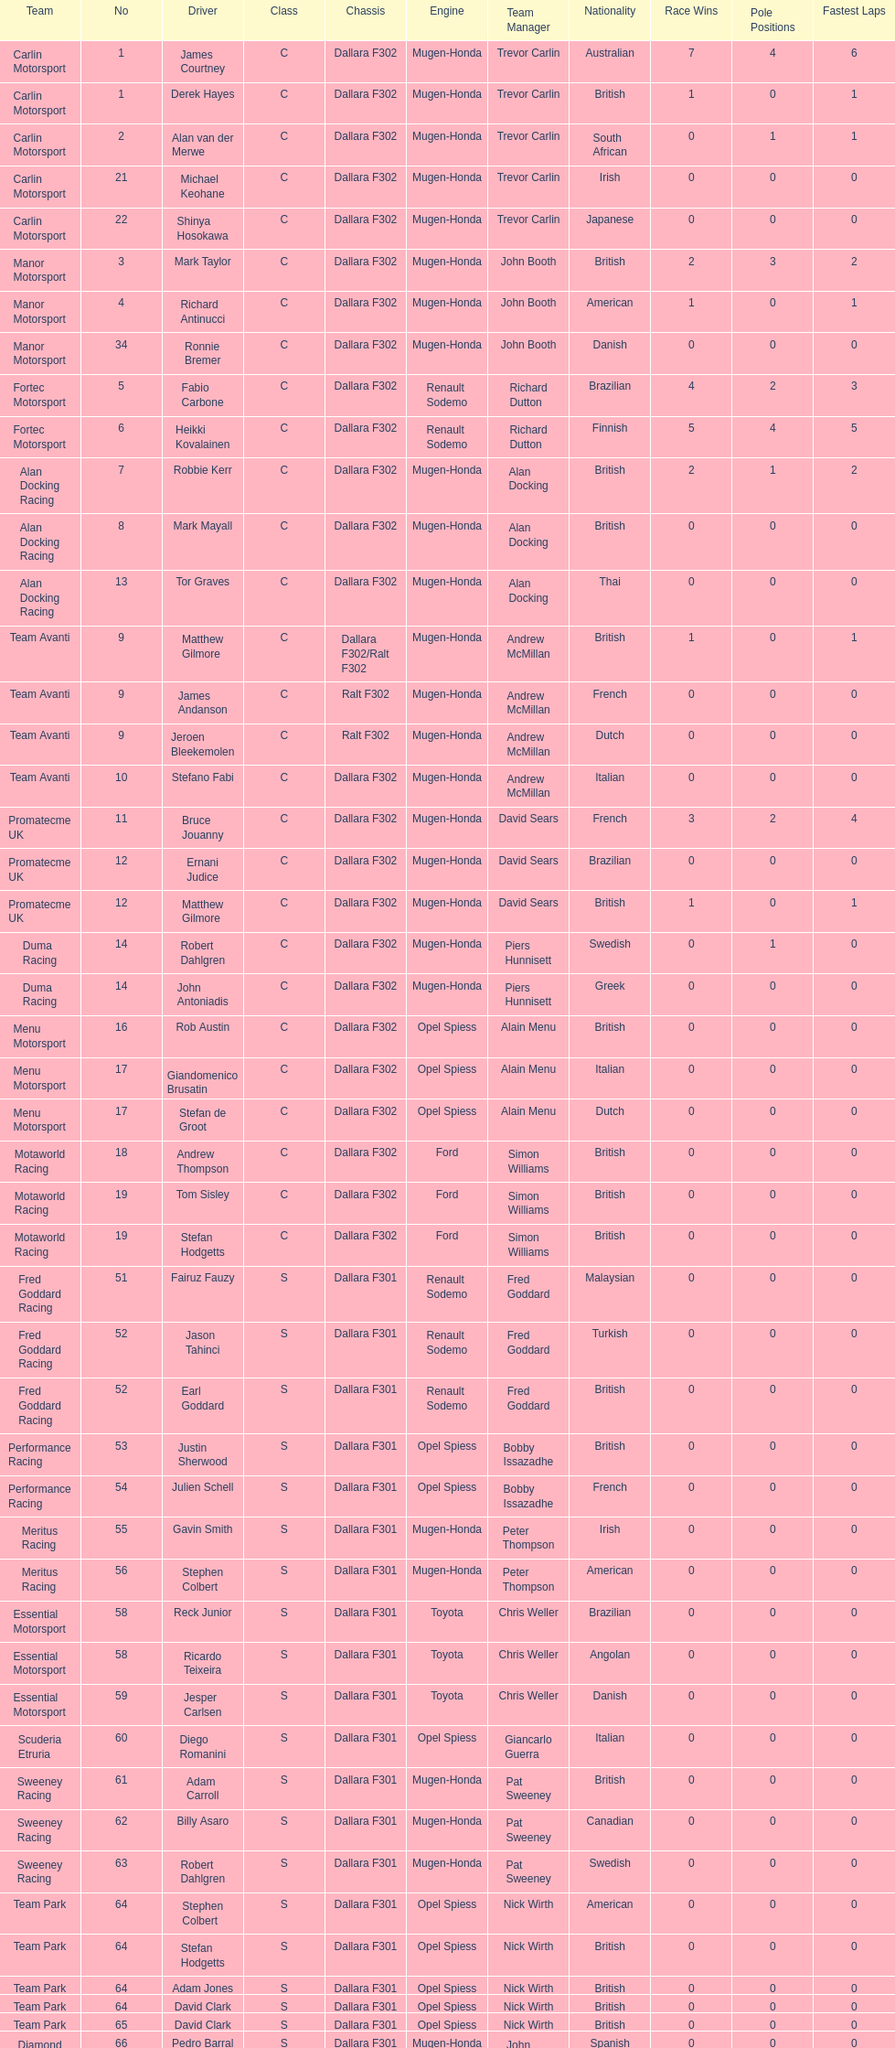Who had more drivers, team avanti or motaworld racing? Team Avanti. 